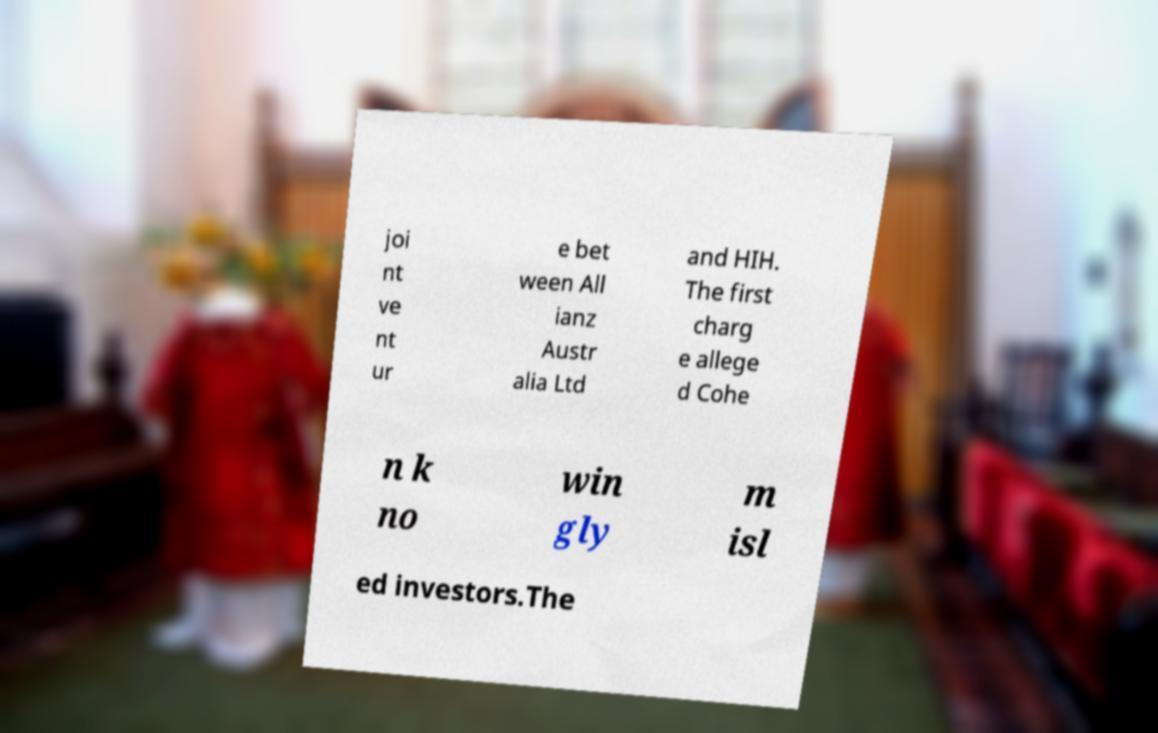For documentation purposes, I need the text within this image transcribed. Could you provide that? joi nt ve nt ur e bet ween All ianz Austr alia Ltd and HIH. The first charg e allege d Cohe n k no win gly m isl ed investors.The 